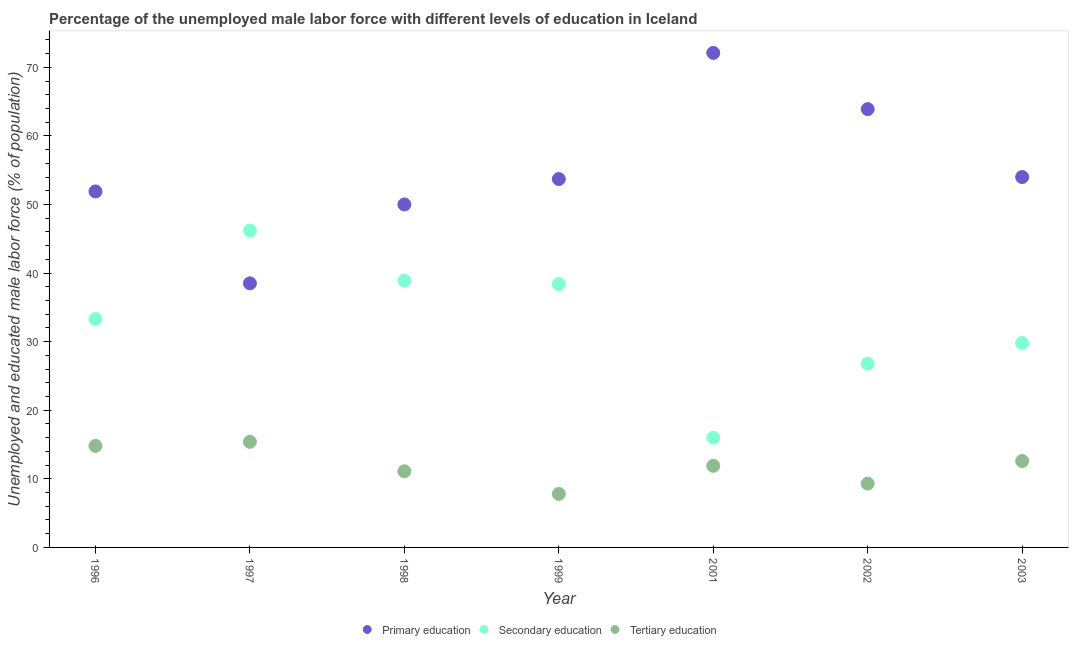How many different coloured dotlines are there?
Ensure brevity in your answer.  3. Is the number of dotlines equal to the number of legend labels?
Offer a very short reply. Yes. What is the percentage of male labor force who received primary education in 1996?
Provide a short and direct response. 51.9. Across all years, what is the maximum percentage of male labor force who received tertiary education?
Your answer should be compact. 15.4. Across all years, what is the minimum percentage of male labor force who received secondary education?
Provide a succinct answer. 16. In which year was the percentage of male labor force who received primary education maximum?
Offer a very short reply. 2001. In which year was the percentage of male labor force who received tertiary education minimum?
Your answer should be compact. 1999. What is the total percentage of male labor force who received primary education in the graph?
Your answer should be compact. 384.1. What is the difference between the percentage of male labor force who received secondary education in 2001 and the percentage of male labor force who received primary education in 1998?
Offer a terse response. -34. What is the average percentage of male labor force who received primary education per year?
Keep it short and to the point. 54.87. In the year 1996, what is the difference between the percentage of male labor force who received primary education and percentage of male labor force who received tertiary education?
Offer a very short reply. 37.1. What is the ratio of the percentage of male labor force who received primary education in 1998 to that in 1999?
Your response must be concise. 0.93. Is the percentage of male labor force who received secondary education in 1998 less than that in 2002?
Make the answer very short. No. What is the difference between the highest and the second highest percentage of male labor force who received tertiary education?
Make the answer very short. 0.6. What is the difference between the highest and the lowest percentage of male labor force who received tertiary education?
Keep it short and to the point. 7.6. Is the percentage of male labor force who received primary education strictly greater than the percentage of male labor force who received secondary education over the years?
Keep it short and to the point. No. How many dotlines are there?
Offer a very short reply. 3. Does the graph contain any zero values?
Give a very brief answer. No. Does the graph contain grids?
Make the answer very short. No. Where does the legend appear in the graph?
Your answer should be compact. Bottom center. How many legend labels are there?
Your response must be concise. 3. What is the title of the graph?
Provide a succinct answer. Percentage of the unemployed male labor force with different levels of education in Iceland. What is the label or title of the Y-axis?
Offer a terse response. Unemployed and educated male labor force (% of population). What is the Unemployed and educated male labor force (% of population) of Primary education in 1996?
Give a very brief answer. 51.9. What is the Unemployed and educated male labor force (% of population) of Secondary education in 1996?
Provide a short and direct response. 33.3. What is the Unemployed and educated male labor force (% of population) of Tertiary education in 1996?
Offer a terse response. 14.8. What is the Unemployed and educated male labor force (% of population) in Primary education in 1997?
Offer a very short reply. 38.5. What is the Unemployed and educated male labor force (% of population) of Secondary education in 1997?
Give a very brief answer. 46.2. What is the Unemployed and educated male labor force (% of population) of Tertiary education in 1997?
Make the answer very short. 15.4. What is the Unemployed and educated male labor force (% of population) of Secondary education in 1998?
Keep it short and to the point. 38.9. What is the Unemployed and educated male labor force (% of population) in Tertiary education in 1998?
Offer a very short reply. 11.1. What is the Unemployed and educated male labor force (% of population) in Primary education in 1999?
Your response must be concise. 53.7. What is the Unemployed and educated male labor force (% of population) in Secondary education in 1999?
Your answer should be very brief. 38.4. What is the Unemployed and educated male labor force (% of population) of Tertiary education in 1999?
Keep it short and to the point. 7.8. What is the Unemployed and educated male labor force (% of population) of Primary education in 2001?
Provide a short and direct response. 72.1. What is the Unemployed and educated male labor force (% of population) in Secondary education in 2001?
Your response must be concise. 16. What is the Unemployed and educated male labor force (% of population) in Tertiary education in 2001?
Offer a very short reply. 11.9. What is the Unemployed and educated male labor force (% of population) of Primary education in 2002?
Offer a very short reply. 63.9. What is the Unemployed and educated male labor force (% of population) of Secondary education in 2002?
Your answer should be very brief. 26.8. What is the Unemployed and educated male labor force (% of population) of Tertiary education in 2002?
Your answer should be very brief. 9.3. What is the Unemployed and educated male labor force (% of population) of Secondary education in 2003?
Provide a short and direct response. 29.8. What is the Unemployed and educated male labor force (% of population) in Tertiary education in 2003?
Offer a very short reply. 12.6. Across all years, what is the maximum Unemployed and educated male labor force (% of population) of Primary education?
Offer a terse response. 72.1. Across all years, what is the maximum Unemployed and educated male labor force (% of population) in Secondary education?
Provide a short and direct response. 46.2. Across all years, what is the maximum Unemployed and educated male labor force (% of population) in Tertiary education?
Ensure brevity in your answer.  15.4. Across all years, what is the minimum Unemployed and educated male labor force (% of population) in Primary education?
Provide a succinct answer. 38.5. Across all years, what is the minimum Unemployed and educated male labor force (% of population) in Secondary education?
Your answer should be very brief. 16. Across all years, what is the minimum Unemployed and educated male labor force (% of population) of Tertiary education?
Provide a succinct answer. 7.8. What is the total Unemployed and educated male labor force (% of population) in Primary education in the graph?
Provide a succinct answer. 384.1. What is the total Unemployed and educated male labor force (% of population) in Secondary education in the graph?
Provide a short and direct response. 229.4. What is the total Unemployed and educated male labor force (% of population) in Tertiary education in the graph?
Provide a short and direct response. 82.9. What is the difference between the Unemployed and educated male labor force (% of population) of Secondary education in 1996 and that in 1997?
Provide a succinct answer. -12.9. What is the difference between the Unemployed and educated male labor force (% of population) in Primary education in 1996 and that in 1998?
Make the answer very short. 1.9. What is the difference between the Unemployed and educated male labor force (% of population) in Tertiary education in 1996 and that in 1998?
Ensure brevity in your answer.  3.7. What is the difference between the Unemployed and educated male labor force (% of population) in Primary education in 1996 and that in 1999?
Ensure brevity in your answer.  -1.8. What is the difference between the Unemployed and educated male labor force (% of population) of Primary education in 1996 and that in 2001?
Provide a short and direct response. -20.2. What is the difference between the Unemployed and educated male labor force (% of population) in Secondary education in 1996 and that in 2001?
Offer a terse response. 17.3. What is the difference between the Unemployed and educated male labor force (% of population) in Primary education in 1996 and that in 2002?
Ensure brevity in your answer.  -12. What is the difference between the Unemployed and educated male labor force (% of population) in Tertiary education in 1997 and that in 1998?
Make the answer very short. 4.3. What is the difference between the Unemployed and educated male labor force (% of population) of Primary education in 1997 and that in 1999?
Offer a terse response. -15.2. What is the difference between the Unemployed and educated male labor force (% of population) of Secondary education in 1997 and that in 1999?
Provide a short and direct response. 7.8. What is the difference between the Unemployed and educated male labor force (% of population) of Primary education in 1997 and that in 2001?
Your response must be concise. -33.6. What is the difference between the Unemployed and educated male labor force (% of population) of Secondary education in 1997 and that in 2001?
Provide a succinct answer. 30.2. What is the difference between the Unemployed and educated male labor force (% of population) of Primary education in 1997 and that in 2002?
Ensure brevity in your answer.  -25.4. What is the difference between the Unemployed and educated male labor force (% of population) of Tertiary education in 1997 and that in 2002?
Give a very brief answer. 6.1. What is the difference between the Unemployed and educated male labor force (% of population) in Primary education in 1997 and that in 2003?
Give a very brief answer. -15.5. What is the difference between the Unemployed and educated male labor force (% of population) in Tertiary education in 1997 and that in 2003?
Your answer should be compact. 2.8. What is the difference between the Unemployed and educated male labor force (% of population) in Secondary education in 1998 and that in 1999?
Give a very brief answer. 0.5. What is the difference between the Unemployed and educated male labor force (% of population) of Tertiary education in 1998 and that in 1999?
Offer a terse response. 3.3. What is the difference between the Unemployed and educated male labor force (% of population) of Primary education in 1998 and that in 2001?
Keep it short and to the point. -22.1. What is the difference between the Unemployed and educated male labor force (% of population) of Secondary education in 1998 and that in 2001?
Give a very brief answer. 22.9. What is the difference between the Unemployed and educated male labor force (% of population) in Tertiary education in 1998 and that in 2001?
Make the answer very short. -0.8. What is the difference between the Unemployed and educated male labor force (% of population) in Primary education in 1998 and that in 2002?
Ensure brevity in your answer.  -13.9. What is the difference between the Unemployed and educated male labor force (% of population) in Secondary education in 1998 and that in 2002?
Make the answer very short. 12.1. What is the difference between the Unemployed and educated male labor force (% of population) of Primary education in 1998 and that in 2003?
Your answer should be compact. -4. What is the difference between the Unemployed and educated male labor force (% of population) of Secondary education in 1998 and that in 2003?
Keep it short and to the point. 9.1. What is the difference between the Unemployed and educated male labor force (% of population) in Tertiary education in 1998 and that in 2003?
Offer a terse response. -1.5. What is the difference between the Unemployed and educated male labor force (% of population) in Primary education in 1999 and that in 2001?
Keep it short and to the point. -18.4. What is the difference between the Unemployed and educated male labor force (% of population) in Secondary education in 1999 and that in 2001?
Provide a succinct answer. 22.4. What is the difference between the Unemployed and educated male labor force (% of population) of Tertiary education in 1999 and that in 2001?
Offer a very short reply. -4.1. What is the difference between the Unemployed and educated male labor force (% of population) of Secondary education in 1999 and that in 2003?
Your answer should be compact. 8.6. What is the difference between the Unemployed and educated male labor force (% of population) in Tertiary education in 1999 and that in 2003?
Provide a short and direct response. -4.8. What is the difference between the Unemployed and educated male labor force (% of population) in Primary education in 2001 and that in 2002?
Ensure brevity in your answer.  8.2. What is the difference between the Unemployed and educated male labor force (% of population) of Secondary education in 2001 and that in 2002?
Keep it short and to the point. -10.8. What is the difference between the Unemployed and educated male labor force (% of population) in Tertiary education in 2001 and that in 2002?
Provide a short and direct response. 2.6. What is the difference between the Unemployed and educated male labor force (% of population) of Tertiary education in 2001 and that in 2003?
Provide a short and direct response. -0.7. What is the difference between the Unemployed and educated male labor force (% of population) of Tertiary education in 2002 and that in 2003?
Make the answer very short. -3.3. What is the difference between the Unemployed and educated male labor force (% of population) in Primary education in 1996 and the Unemployed and educated male labor force (% of population) in Secondary education in 1997?
Your response must be concise. 5.7. What is the difference between the Unemployed and educated male labor force (% of population) of Primary education in 1996 and the Unemployed and educated male labor force (% of population) of Tertiary education in 1997?
Make the answer very short. 36.5. What is the difference between the Unemployed and educated male labor force (% of population) in Primary education in 1996 and the Unemployed and educated male labor force (% of population) in Tertiary education in 1998?
Provide a succinct answer. 40.8. What is the difference between the Unemployed and educated male labor force (% of population) of Secondary education in 1996 and the Unemployed and educated male labor force (% of population) of Tertiary education in 1998?
Your answer should be compact. 22.2. What is the difference between the Unemployed and educated male labor force (% of population) in Primary education in 1996 and the Unemployed and educated male labor force (% of population) in Secondary education in 1999?
Give a very brief answer. 13.5. What is the difference between the Unemployed and educated male labor force (% of population) in Primary education in 1996 and the Unemployed and educated male labor force (% of population) in Tertiary education in 1999?
Your response must be concise. 44.1. What is the difference between the Unemployed and educated male labor force (% of population) in Secondary education in 1996 and the Unemployed and educated male labor force (% of population) in Tertiary education in 1999?
Your response must be concise. 25.5. What is the difference between the Unemployed and educated male labor force (% of population) in Primary education in 1996 and the Unemployed and educated male labor force (% of population) in Secondary education in 2001?
Offer a terse response. 35.9. What is the difference between the Unemployed and educated male labor force (% of population) of Secondary education in 1996 and the Unemployed and educated male labor force (% of population) of Tertiary education in 2001?
Provide a succinct answer. 21.4. What is the difference between the Unemployed and educated male labor force (% of population) in Primary education in 1996 and the Unemployed and educated male labor force (% of population) in Secondary education in 2002?
Ensure brevity in your answer.  25.1. What is the difference between the Unemployed and educated male labor force (% of population) in Primary education in 1996 and the Unemployed and educated male labor force (% of population) in Tertiary education in 2002?
Offer a terse response. 42.6. What is the difference between the Unemployed and educated male labor force (% of population) in Secondary education in 1996 and the Unemployed and educated male labor force (% of population) in Tertiary education in 2002?
Keep it short and to the point. 24. What is the difference between the Unemployed and educated male labor force (% of population) in Primary education in 1996 and the Unemployed and educated male labor force (% of population) in Secondary education in 2003?
Your answer should be very brief. 22.1. What is the difference between the Unemployed and educated male labor force (% of population) in Primary education in 1996 and the Unemployed and educated male labor force (% of population) in Tertiary education in 2003?
Provide a short and direct response. 39.3. What is the difference between the Unemployed and educated male labor force (% of population) of Secondary education in 1996 and the Unemployed and educated male labor force (% of population) of Tertiary education in 2003?
Your answer should be very brief. 20.7. What is the difference between the Unemployed and educated male labor force (% of population) of Primary education in 1997 and the Unemployed and educated male labor force (% of population) of Tertiary education in 1998?
Your answer should be very brief. 27.4. What is the difference between the Unemployed and educated male labor force (% of population) in Secondary education in 1997 and the Unemployed and educated male labor force (% of population) in Tertiary education in 1998?
Give a very brief answer. 35.1. What is the difference between the Unemployed and educated male labor force (% of population) of Primary education in 1997 and the Unemployed and educated male labor force (% of population) of Tertiary education in 1999?
Keep it short and to the point. 30.7. What is the difference between the Unemployed and educated male labor force (% of population) in Secondary education in 1997 and the Unemployed and educated male labor force (% of population) in Tertiary education in 1999?
Your answer should be very brief. 38.4. What is the difference between the Unemployed and educated male labor force (% of population) in Primary education in 1997 and the Unemployed and educated male labor force (% of population) in Tertiary education in 2001?
Ensure brevity in your answer.  26.6. What is the difference between the Unemployed and educated male labor force (% of population) of Secondary education in 1997 and the Unemployed and educated male labor force (% of population) of Tertiary education in 2001?
Ensure brevity in your answer.  34.3. What is the difference between the Unemployed and educated male labor force (% of population) in Primary education in 1997 and the Unemployed and educated male labor force (% of population) in Tertiary education in 2002?
Your answer should be very brief. 29.2. What is the difference between the Unemployed and educated male labor force (% of population) of Secondary education in 1997 and the Unemployed and educated male labor force (% of population) of Tertiary education in 2002?
Ensure brevity in your answer.  36.9. What is the difference between the Unemployed and educated male labor force (% of population) in Primary education in 1997 and the Unemployed and educated male labor force (% of population) in Tertiary education in 2003?
Ensure brevity in your answer.  25.9. What is the difference between the Unemployed and educated male labor force (% of population) in Secondary education in 1997 and the Unemployed and educated male labor force (% of population) in Tertiary education in 2003?
Ensure brevity in your answer.  33.6. What is the difference between the Unemployed and educated male labor force (% of population) in Primary education in 1998 and the Unemployed and educated male labor force (% of population) in Tertiary education in 1999?
Give a very brief answer. 42.2. What is the difference between the Unemployed and educated male labor force (% of population) of Secondary education in 1998 and the Unemployed and educated male labor force (% of population) of Tertiary education in 1999?
Provide a short and direct response. 31.1. What is the difference between the Unemployed and educated male labor force (% of population) of Primary education in 1998 and the Unemployed and educated male labor force (% of population) of Tertiary education in 2001?
Ensure brevity in your answer.  38.1. What is the difference between the Unemployed and educated male labor force (% of population) of Primary education in 1998 and the Unemployed and educated male labor force (% of population) of Secondary education in 2002?
Keep it short and to the point. 23.2. What is the difference between the Unemployed and educated male labor force (% of population) of Primary education in 1998 and the Unemployed and educated male labor force (% of population) of Tertiary education in 2002?
Give a very brief answer. 40.7. What is the difference between the Unemployed and educated male labor force (% of population) in Secondary education in 1998 and the Unemployed and educated male labor force (% of population) in Tertiary education in 2002?
Make the answer very short. 29.6. What is the difference between the Unemployed and educated male labor force (% of population) of Primary education in 1998 and the Unemployed and educated male labor force (% of population) of Secondary education in 2003?
Provide a short and direct response. 20.2. What is the difference between the Unemployed and educated male labor force (% of population) of Primary education in 1998 and the Unemployed and educated male labor force (% of population) of Tertiary education in 2003?
Provide a succinct answer. 37.4. What is the difference between the Unemployed and educated male labor force (% of population) of Secondary education in 1998 and the Unemployed and educated male labor force (% of population) of Tertiary education in 2003?
Your response must be concise. 26.3. What is the difference between the Unemployed and educated male labor force (% of population) in Primary education in 1999 and the Unemployed and educated male labor force (% of population) in Secondary education in 2001?
Offer a terse response. 37.7. What is the difference between the Unemployed and educated male labor force (% of population) of Primary education in 1999 and the Unemployed and educated male labor force (% of population) of Tertiary education in 2001?
Your answer should be compact. 41.8. What is the difference between the Unemployed and educated male labor force (% of population) in Primary education in 1999 and the Unemployed and educated male labor force (% of population) in Secondary education in 2002?
Offer a terse response. 26.9. What is the difference between the Unemployed and educated male labor force (% of population) of Primary education in 1999 and the Unemployed and educated male labor force (% of population) of Tertiary education in 2002?
Keep it short and to the point. 44.4. What is the difference between the Unemployed and educated male labor force (% of population) of Secondary education in 1999 and the Unemployed and educated male labor force (% of population) of Tertiary education in 2002?
Give a very brief answer. 29.1. What is the difference between the Unemployed and educated male labor force (% of population) in Primary education in 1999 and the Unemployed and educated male labor force (% of population) in Secondary education in 2003?
Keep it short and to the point. 23.9. What is the difference between the Unemployed and educated male labor force (% of population) of Primary education in 1999 and the Unemployed and educated male labor force (% of population) of Tertiary education in 2003?
Your answer should be compact. 41.1. What is the difference between the Unemployed and educated male labor force (% of population) in Secondary education in 1999 and the Unemployed and educated male labor force (% of population) in Tertiary education in 2003?
Make the answer very short. 25.8. What is the difference between the Unemployed and educated male labor force (% of population) in Primary education in 2001 and the Unemployed and educated male labor force (% of population) in Secondary education in 2002?
Give a very brief answer. 45.3. What is the difference between the Unemployed and educated male labor force (% of population) of Primary education in 2001 and the Unemployed and educated male labor force (% of population) of Tertiary education in 2002?
Offer a very short reply. 62.8. What is the difference between the Unemployed and educated male labor force (% of population) in Secondary education in 2001 and the Unemployed and educated male labor force (% of population) in Tertiary education in 2002?
Provide a succinct answer. 6.7. What is the difference between the Unemployed and educated male labor force (% of population) of Primary education in 2001 and the Unemployed and educated male labor force (% of population) of Secondary education in 2003?
Provide a short and direct response. 42.3. What is the difference between the Unemployed and educated male labor force (% of population) in Primary education in 2001 and the Unemployed and educated male labor force (% of population) in Tertiary education in 2003?
Your answer should be compact. 59.5. What is the difference between the Unemployed and educated male labor force (% of population) of Primary education in 2002 and the Unemployed and educated male labor force (% of population) of Secondary education in 2003?
Offer a very short reply. 34.1. What is the difference between the Unemployed and educated male labor force (% of population) of Primary education in 2002 and the Unemployed and educated male labor force (% of population) of Tertiary education in 2003?
Keep it short and to the point. 51.3. What is the difference between the Unemployed and educated male labor force (% of population) of Secondary education in 2002 and the Unemployed and educated male labor force (% of population) of Tertiary education in 2003?
Ensure brevity in your answer.  14.2. What is the average Unemployed and educated male labor force (% of population) of Primary education per year?
Your answer should be compact. 54.87. What is the average Unemployed and educated male labor force (% of population) in Secondary education per year?
Provide a succinct answer. 32.77. What is the average Unemployed and educated male labor force (% of population) in Tertiary education per year?
Keep it short and to the point. 11.84. In the year 1996, what is the difference between the Unemployed and educated male labor force (% of population) in Primary education and Unemployed and educated male labor force (% of population) in Secondary education?
Your answer should be very brief. 18.6. In the year 1996, what is the difference between the Unemployed and educated male labor force (% of population) of Primary education and Unemployed and educated male labor force (% of population) of Tertiary education?
Your response must be concise. 37.1. In the year 1996, what is the difference between the Unemployed and educated male labor force (% of population) of Secondary education and Unemployed and educated male labor force (% of population) of Tertiary education?
Your answer should be compact. 18.5. In the year 1997, what is the difference between the Unemployed and educated male labor force (% of population) of Primary education and Unemployed and educated male labor force (% of population) of Tertiary education?
Provide a succinct answer. 23.1. In the year 1997, what is the difference between the Unemployed and educated male labor force (% of population) of Secondary education and Unemployed and educated male labor force (% of population) of Tertiary education?
Keep it short and to the point. 30.8. In the year 1998, what is the difference between the Unemployed and educated male labor force (% of population) of Primary education and Unemployed and educated male labor force (% of population) of Tertiary education?
Your response must be concise. 38.9. In the year 1998, what is the difference between the Unemployed and educated male labor force (% of population) of Secondary education and Unemployed and educated male labor force (% of population) of Tertiary education?
Make the answer very short. 27.8. In the year 1999, what is the difference between the Unemployed and educated male labor force (% of population) of Primary education and Unemployed and educated male labor force (% of population) of Secondary education?
Your response must be concise. 15.3. In the year 1999, what is the difference between the Unemployed and educated male labor force (% of population) of Primary education and Unemployed and educated male labor force (% of population) of Tertiary education?
Offer a terse response. 45.9. In the year 1999, what is the difference between the Unemployed and educated male labor force (% of population) in Secondary education and Unemployed and educated male labor force (% of population) in Tertiary education?
Your answer should be compact. 30.6. In the year 2001, what is the difference between the Unemployed and educated male labor force (% of population) of Primary education and Unemployed and educated male labor force (% of population) of Secondary education?
Keep it short and to the point. 56.1. In the year 2001, what is the difference between the Unemployed and educated male labor force (% of population) in Primary education and Unemployed and educated male labor force (% of population) in Tertiary education?
Offer a very short reply. 60.2. In the year 2002, what is the difference between the Unemployed and educated male labor force (% of population) of Primary education and Unemployed and educated male labor force (% of population) of Secondary education?
Keep it short and to the point. 37.1. In the year 2002, what is the difference between the Unemployed and educated male labor force (% of population) of Primary education and Unemployed and educated male labor force (% of population) of Tertiary education?
Provide a short and direct response. 54.6. In the year 2003, what is the difference between the Unemployed and educated male labor force (% of population) of Primary education and Unemployed and educated male labor force (% of population) of Secondary education?
Give a very brief answer. 24.2. In the year 2003, what is the difference between the Unemployed and educated male labor force (% of population) of Primary education and Unemployed and educated male labor force (% of population) of Tertiary education?
Your response must be concise. 41.4. In the year 2003, what is the difference between the Unemployed and educated male labor force (% of population) in Secondary education and Unemployed and educated male labor force (% of population) in Tertiary education?
Your answer should be very brief. 17.2. What is the ratio of the Unemployed and educated male labor force (% of population) in Primary education in 1996 to that in 1997?
Make the answer very short. 1.35. What is the ratio of the Unemployed and educated male labor force (% of population) in Secondary education in 1996 to that in 1997?
Give a very brief answer. 0.72. What is the ratio of the Unemployed and educated male labor force (% of population) of Primary education in 1996 to that in 1998?
Ensure brevity in your answer.  1.04. What is the ratio of the Unemployed and educated male labor force (% of population) in Secondary education in 1996 to that in 1998?
Ensure brevity in your answer.  0.86. What is the ratio of the Unemployed and educated male labor force (% of population) of Primary education in 1996 to that in 1999?
Offer a terse response. 0.97. What is the ratio of the Unemployed and educated male labor force (% of population) in Secondary education in 1996 to that in 1999?
Provide a short and direct response. 0.87. What is the ratio of the Unemployed and educated male labor force (% of population) of Tertiary education in 1996 to that in 1999?
Your answer should be compact. 1.9. What is the ratio of the Unemployed and educated male labor force (% of population) of Primary education in 1996 to that in 2001?
Offer a terse response. 0.72. What is the ratio of the Unemployed and educated male labor force (% of population) of Secondary education in 1996 to that in 2001?
Provide a succinct answer. 2.08. What is the ratio of the Unemployed and educated male labor force (% of population) of Tertiary education in 1996 to that in 2001?
Offer a very short reply. 1.24. What is the ratio of the Unemployed and educated male labor force (% of population) of Primary education in 1996 to that in 2002?
Your response must be concise. 0.81. What is the ratio of the Unemployed and educated male labor force (% of population) in Secondary education in 1996 to that in 2002?
Your response must be concise. 1.24. What is the ratio of the Unemployed and educated male labor force (% of population) in Tertiary education in 1996 to that in 2002?
Give a very brief answer. 1.59. What is the ratio of the Unemployed and educated male labor force (% of population) of Primary education in 1996 to that in 2003?
Keep it short and to the point. 0.96. What is the ratio of the Unemployed and educated male labor force (% of population) in Secondary education in 1996 to that in 2003?
Offer a terse response. 1.12. What is the ratio of the Unemployed and educated male labor force (% of population) of Tertiary education in 1996 to that in 2003?
Your answer should be compact. 1.17. What is the ratio of the Unemployed and educated male labor force (% of population) in Primary education in 1997 to that in 1998?
Make the answer very short. 0.77. What is the ratio of the Unemployed and educated male labor force (% of population) in Secondary education in 1997 to that in 1998?
Provide a succinct answer. 1.19. What is the ratio of the Unemployed and educated male labor force (% of population) in Tertiary education in 1997 to that in 1998?
Provide a short and direct response. 1.39. What is the ratio of the Unemployed and educated male labor force (% of population) of Primary education in 1997 to that in 1999?
Your answer should be very brief. 0.72. What is the ratio of the Unemployed and educated male labor force (% of population) in Secondary education in 1997 to that in 1999?
Give a very brief answer. 1.2. What is the ratio of the Unemployed and educated male labor force (% of population) in Tertiary education in 1997 to that in 1999?
Your response must be concise. 1.97. What is the ratio of the Unemployed and educated male labor force (% of population) of Primary education in 1997 to that in 2001?
Your answer should be compact. 0.53. What is the ratio of the Unemployed and educated male labor force (% of population) of Secondary education in 1997 to that in 2001?
Your answer should be very brief. 2.89. What is the ratio of the Unemployed and educated male labor force (% of population) of Tertiary education in 1997 to that in 2001?
Offer a terse response. 1.29. What is the ratio of the Unemployed and educated male labor force (% of population) of Primary education in 1997 to that in 2002?
Offer a terse response. 0.6. What is the ratio of the Unemployed and educated male labor force (% of population) in Secondary education in 1997 to that in 2002?
Your answer should be very brief. 1.72. What is the ratio of the Unemployed and educated male labor force (% of population) of Tertiary education in 1997 to that in 2002?
Provide a short and direct response. 1.66. What is the ratio of the Unemployed and educated male labor force (% of population) in Primary education in 1997 to that in 2003?
Provide a short and direct response. 0.71. What is the ratio of the Unemployed and educated male labor force (% of population) in Secondary education in 1997 to that in 2003?
Your answer should be very brief. 1.55. What is the ratio of the Unemployed and educated male labor force (% of population) in Tertiary education in 1997 to that in 2003?
Make the answer very short. 1.22. What is the ratio of the Unemployed and educated male labor force (% of population) of Primary education in 1998 to that in 1999?
Provide a short and direct response. 0.93. What is the ratio of the Unemployed and educated male labor force (% of population) of Tertiary education in 1998 to that in 1999?
Provide a succinct answer. 1.42. What is the ratio of the Unemployed and educated male labor force (% of population) of Primary education in 1998 to that in 2001?
Provide a succinct answer. 0.69. What is the ratio of the Unemployed and educated male labor force (% of population) of Secondary education in 1998 to that in 2001?
Make the answer very short. 2.43. What is the ratio of the Unemployed and educated male labor force (% of population) in Tertiary education in 1998 to that in 2001?
Offer a terse response. 0.93. What is the ratio of the Unemployed and educated male labor force (% of population) in Primary education in 1998 to that in 2002?
Your answer should be compact. 0.78. What is the ratio of the Unemployed and educated male labor force (% of population) of Secondary education in 1998 to that in 2002?
Offer a very short reply. 1.45. What is the ratio of the Unemployed and educated male labor force (% of population) in Tertiary education in 1998 to that in 2002?
Provide a short and direct response. 1.19. What is the ratio of the Unemployed and educated male labor force (% of population) in Primary education in 1998 to that in 2003?
Your answer should be very brief. 0.93. What is the ratio of the Unemployed and educated male labor force (% of population) in Secondary education in 1998 to that in 2003?
Keep it short and to the point. 1.31. What is the ratio of the Unemployed and educated male labor force (% of population) of Tertiary education in 1998 to that in 2003?
Your answer should be compact. 0.88. What is the ratio of the Unemployed and educated male labor force (% of population) of Primary education in 1999 to that in 2001?
Offer a very short reply. 0.74. What is the ratio of the Unemployed and educated male labor force (% of population) in Secondary education in 1999 to that in 2001?
Ensure brevity in your answer.  2.4. What is the ratio of the Unemployed and educated male labor force (% of population) in Tertiary education in 1999 to that in 2001?
Your response must be concise. 0.66. What is the ratio of the Unemployed and educated male labor force (% of population) in Primary education in 1999 to that in 2002?
Your answer should be compact. 0.84. What is the ratio of the Unemployed and educated male labor force (% of population) in Secondary education in 1999 to that in 2002?
Give a very brief answer. 1.43. What is the ratio of the Unemployed and educated male labor force (% of population) in Tertiary education in 1999 to that in 2002?
Provide a succinct answer. 0.84. What is the ratio of the Unemployed and educated male labor force (% of population) in Secondary education in 1999 to that in 2003?
Your answer should be compact. 1.29. What is the ratio of the Unemployed and educated male labor force (% of population) of Tertiary education in 1999 to that in 2003?
Ensure brevity in your answer.  0.62. What is the ratio of the Unemployed and educated male labor force (% of population) of Primary education in 2001 to that in 2002?
Provide a succinct answer. 1.13. What is the ratio of the Unemployed and educated male labor force (% of population) of Secondary education in 2001 to that in 2002?
Your response must be concise. 0.6. What is the ratio of the Unemployed and educated male labor force (% of population) in Tertiary education in 2001 to that in 2002?
Offer a very short reply. 1.28. What is the ratio of the Unemployed and educated male labor force (% of population) in Primary education in 2001 to that in 2003?
Offer a very short reply. 1.34. What is the ratio of the Unemployed and educated male labor force (% of population) of Secondary education in 2001 to that in 2003?
Keep it short and to the point. 0.54. What is the ratio of the Unemployed and educated male labor force (% of population) in Tertiary education in 2001 to that in 2003?
Ensure brevity in your answer.  0.94. What is the ratio of the Unemployed and educated male labor force (% of population) in Primary education in 2002 to that in 2003?
Your answer should be very brief. 1.18. What is the ratio of the Unemployed and educated male labor force (% of population) in Secondary education in 2002 to that in 2003?
Offer a terse response. 0.9. What is the ratio of the Unemployed and educated male labor force (% of population) in Tertiary education in 2002 to that in 2003?
Offer a very short reply. 0.74. What is the difference between the highest and the second highest Unemployed and educated male labor force (% of population) of Secondary education?
Provide a short and direct response. 7.3. What is the difference between the highest and the second highest Unemployed and educated male labor force (% of population) in Tertiary education?
Give a very brief answer. 0.6. What is the difference between the highest and the lowest Unemployed and educated male labor force (% of population) of Primary education?
Offer a very short reply. 33.6. What is the difference between the highest and the lowest Unemployed and educated male labor force (% of population) in Secondary education?
Provide a succinct answer. 30.2. 